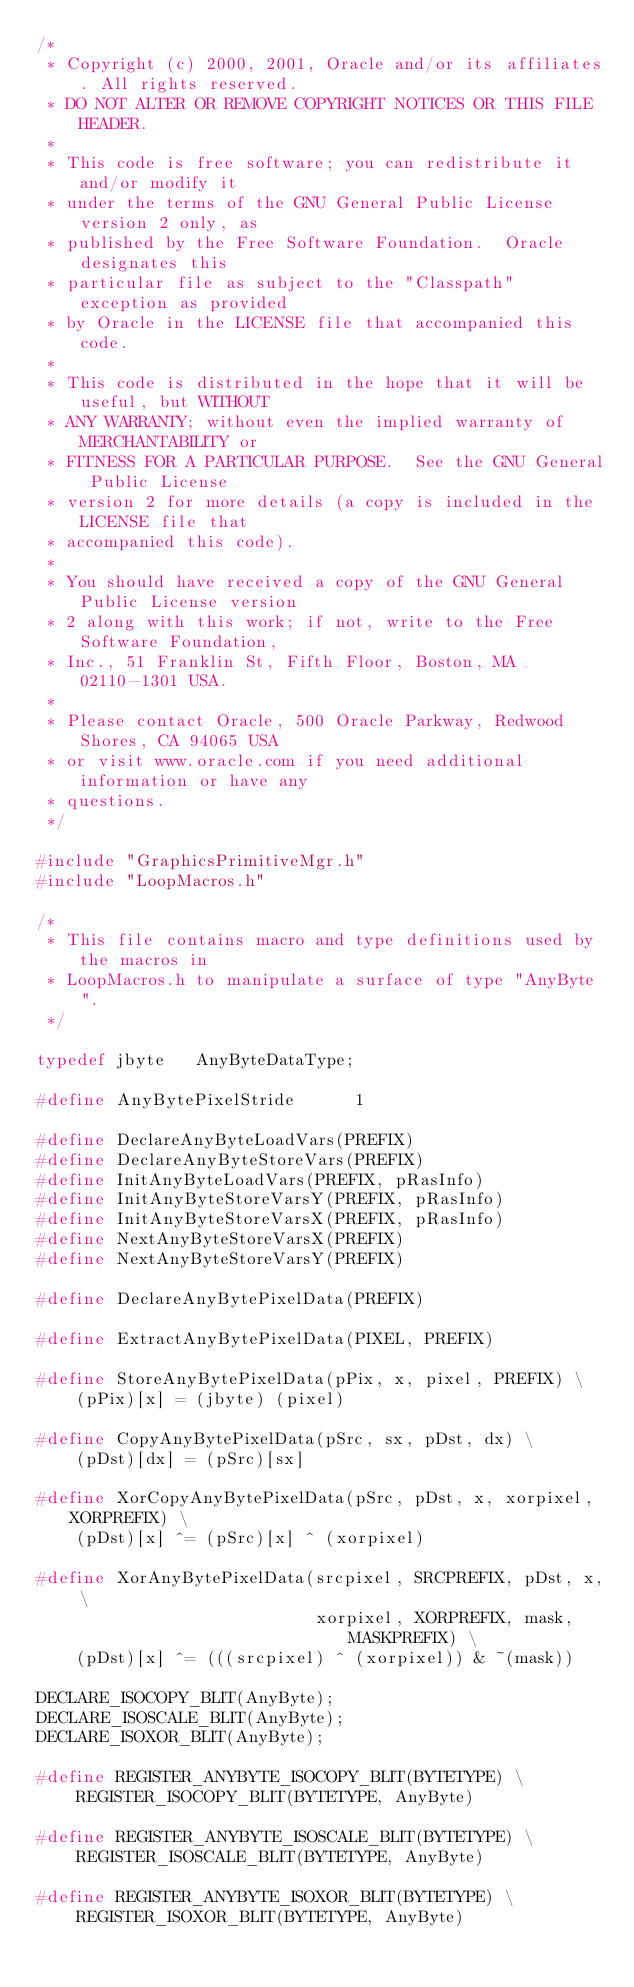Convert code to text. <code><loc_0><loc_0><loc_500><loc_500><_C_>/*
 * Copyright (c) 2000, 2001, Oracle and/or its affiliates. All rights reserved.
 * DO NOT ALTER OR REMOVE COPYRIGHT NOTICES OR THIS FILE HEADER.
 *
 * This code is free software; you can redistribute it and/or modify it
 * under the terms of the GNU General Public License version 2 only, as
 * published by the Free Software Foundation.  Oracle designates this
 * particular file as subject to the "Classpath" exception as provided
 * by Oracle in the LICENSE file that accompanied this code.
 *
 * This code is distributed in the hope that it will be useful, but WITHOUT
 * ANY WARRANTY; without even the implied warranty of MERCHANTABILITY or
 * FITNESS FOR A PARTICULAR PURPOSE.  See the GNU General Public License
 * version 2 for more details (a copy is included in the LICENSE file that
 * accompanied this code).
 *
 * You should have received a copy of the GNU General Public License version
 * 2 along with this work; if not, write to the Free Software Foundation,
 * Inc., 51 Franklin St, Fifth Floor, Boston, MA 02110-1301 USA.
 *
 * Please contact Oracle, 500 Oracle Parkway, Redwood Shores, CA 94065 USA
 * or visit www.oracle.com if you need additional information or have any
 * questions.
 */

#include "GraphicsPrimitiveMgr.h"
#include "LoopMacros.h"

/*
 * This file contains macro and type definitions used by the macros in
 * LoopMacros.h to manipulate a surface of type "AnyByte".
 */

typedef jbyte   AnyByteDataType;

#define AnyBytePixelStride      1

#define DeclareAnyByteLoadVars(PREFIX)
#define DeclareAnyByteStoreVars(PREFIX)
#define InitAnyByteLoadVars(PREFIX, pRasInfo)
#define InitAnyByteStoreVarsY(PREFIX, pRasInfo)
#define InitAnyByteStoreVarsX(PREFIX, pRasInfo)
#define NextAnyByteStoreVarsX(PREFIX)
#define NextAnyByteStoreVarsY(PREFIX)

#define DeclareAnyBytePixelData(PREFIX)

#define ExtractAnyBytePixelData(PIXEL, PREFIX)

#define StoreAnyBytePixelData(pPix, x, pixel, PREFIX) \
    (pPix)[x] = (jbyte) (pixel)

#define CopyAnyBytePixelData(pSrc, sx, pDst, dx) \
    (pDst)[dx] = (pSrc)[sx]

#define XorCopyAnyBytePixelData(pSrc, pDst, x, xorpixel, XORPREFIX) \
    (pDst)[x] ^= (pSrc)[x] ^ (xorpixel)

#define XorAnyBytePixelData(srcpixel, SRCPREFIX, pDst, x, \
                            xorpixel, XORPREFIX, mask, MASKPREFIX) \
    (pDst)[x] ^= (((srcpixel) ^ (xorpixel)) & ~(mask))

DECLARE_ISOCOPY_BLIT(AnyByte);
DECLARE_ISOSCALE_BLIT(AnyByte);
DECLARE_ISOXOR_BLIT(AnyByte);

#define REGISTER_ANYBYTE_ISOCOPY_BLIT(BYTETYPE) \
    REGISTER_ISOCOPY_BLIT(BYTETYPE, AnyByte)

#define REGISTER_ANYBYTE_ISOSCALE_BLIT(BYTETYPE) \
    REGISTER_ISOSCALE_BLIT(BYTETYPE, AnyByte)

#define REGISTER_ANYBYTE_ISOXOR_BLIT(BYTETYPE) \
    REGISTER_ISOXOR_BLIT(BYTETYPE, AnyByte)
</code> 